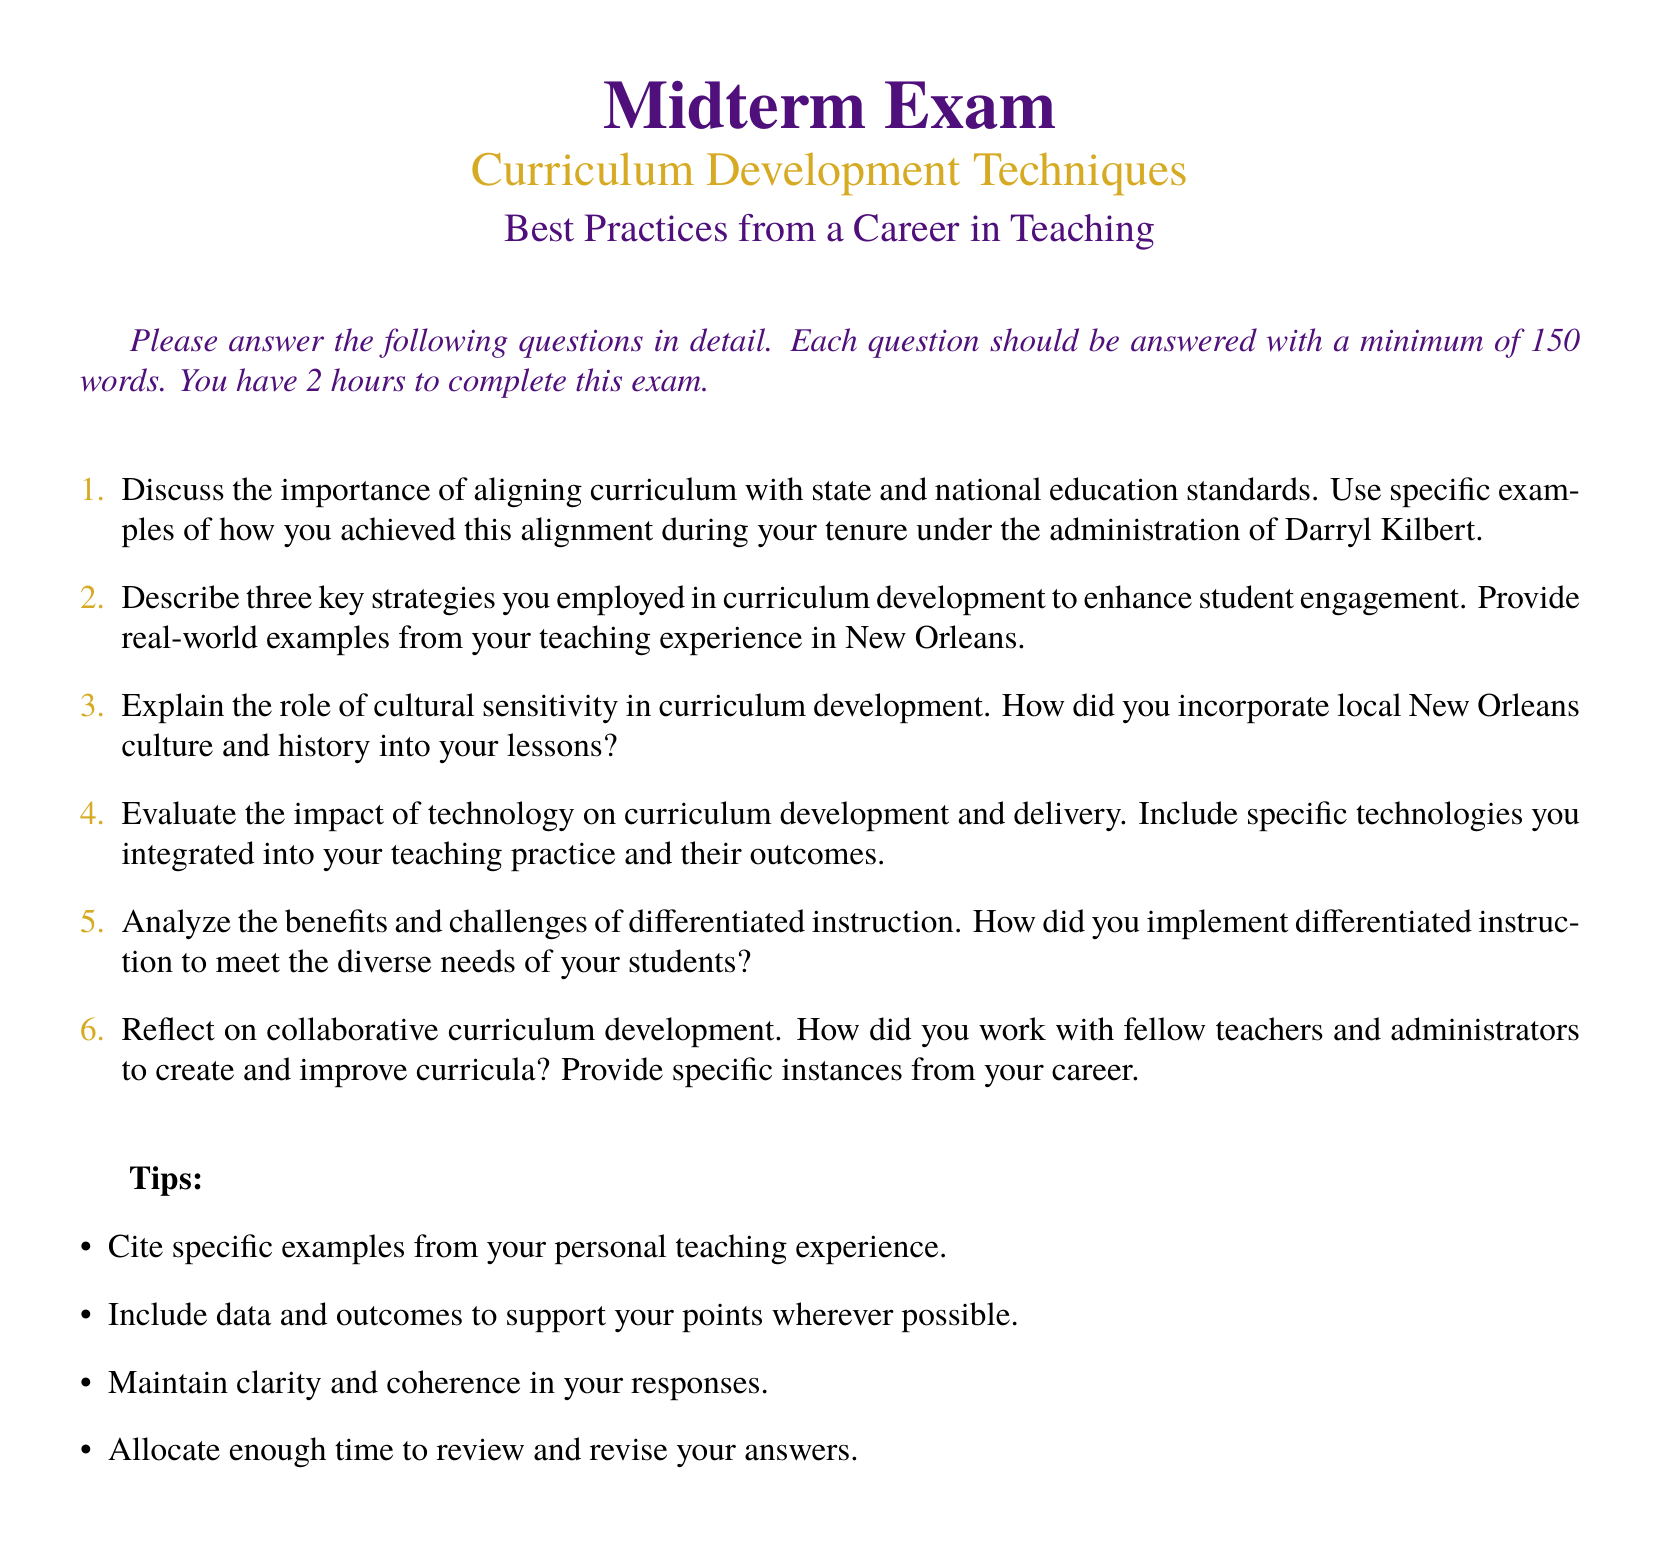What is the title of the exam? The title of the exam appears prominently at the top of the document as "Midterm Exam."
Answer: Midterm Exam What color is used for the section title font? The section title font is defined in the document as a specific color, which is neworleanspurple.
Answer: neworleanspurple How many questions are included in the exam? The exam contains a total of six questions as listed in the enumerated format.
Answer: 6 What is the minimum word count required for each answer? The instructions state that each question should be answered with a minimum of 150 words.
Answer: 150 words Who was the administration under which the author worked? The document specifically mentions that the author's tenure was under the administration of Darryl Kilbert.
Answer: Darryl Kilbert What is emphasized as an important element in curriculum development within the exam? The document highlights the importance of aligning curriculum with state and national education standards in the first question.
Answer: aligning curriculum with state and national education standards What technology aspect is being evaluated in the exam? The exam prompts students to evaluate the impact of technology on curriculum development and delivery in one of the questions.
Answer: impact of technology on curriculum development How are students instructed to support their answers? The tips section encourages students to cite specific examples from their personal teaching experience.
Answer: cite specific examples from personal teaching experience What time is allotted for completing the exam? The instructions indicate that students have 2 hours to complete the exam.
Answer: 2 hours 